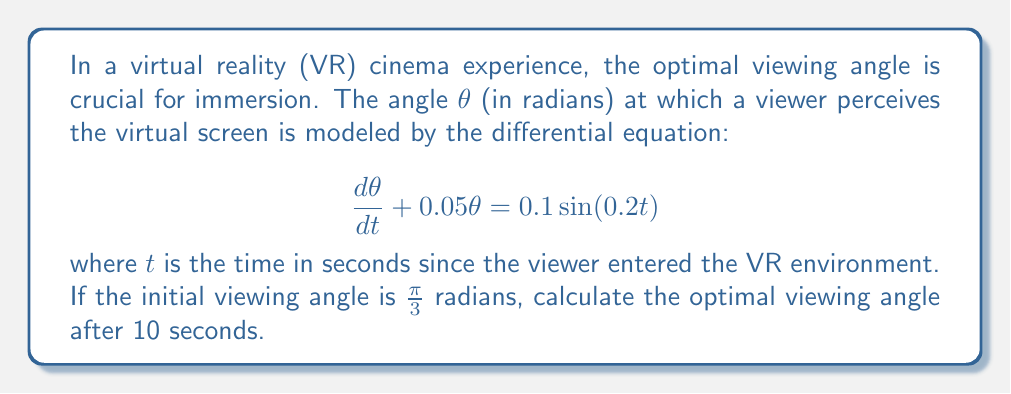Give your solution to this math problem. To solve this first-order linear differential equation, we'll use the integrating factor method:

1) The integrating factor is $\mu(t) = e^{\int 0.05 dt} = e^{0.05t}$

2) Multiply both sides of the equation by $\mu(t)$:

   $e^{0.05t}\frac{d\theta}{dt} + 0.05e^{0.05t}\theta = 0.1e^{0.05t}\sin(0.2t)$

3) The left side is now the derivative of $e^{0.05t}\theta$, so we can write:

   $\frac{d}{dt}(e^{0.05t}\theta) = 0.1e^{0.05t}\sin(0.2t)$

4) Integrate both sides:

   $e^{0.05t}\theta = 0.1\int e^{0.05t}\sin(0.2t)dt$

5) The integral on the right side can be solved using integration by parts:

   $\int e^{0.05t}\sin(0.2t)dt = e^{0.05t}(\frac{0.2\sin(0.2t) - 0.05\cos(0.2t)}{0.05^2 + 0.2^2}) + C$

6) Substituting back:

   $e^{0.05t}\theta = 0.1e^{0.05t}(\frac{0.2\sin(0.2t) - 0.05\cos(0.2t)}{0.05^2 + 0.2^2}) + C$

7) Divide both sides by $e^{0.05t}$:

   $\theta = 0.1(\frac{0.2\sin(0.2t) - 0.05\cos(0.2t)}{0.05^2 + 0.2^2}) + Ce^{-0.05t}$

8) Use the initial condition $\theta(0) = \frac{\pi}{3}$ to find $C$:

   $\frac{\pi}{3} = 0.1(\frac{-0.05}{0.05^2 + 0.2^2}) + C$

   $C = \frac{\pi}{3} + 0.1(\frac{0.05}{0.05^2 + 0.2^2})$

9) The final solution is:

   $\theta(t) = 0.1(\frac{0.2\sin(0.2t) - 0.05\cos(0.2t)}{0.05^2 + 0.2^2}) + (\frac{\pi}{3} + 0.1(\frac{0.05}{0.05^2 + 0.2^2}))e^{-0.05t}$

10) Evaluate $\theta(10)$ to find the viewing angle after 10 seconds.
Answer: $\theta(10) \approx 0.9747$ radians or approximately $55.86°$ 